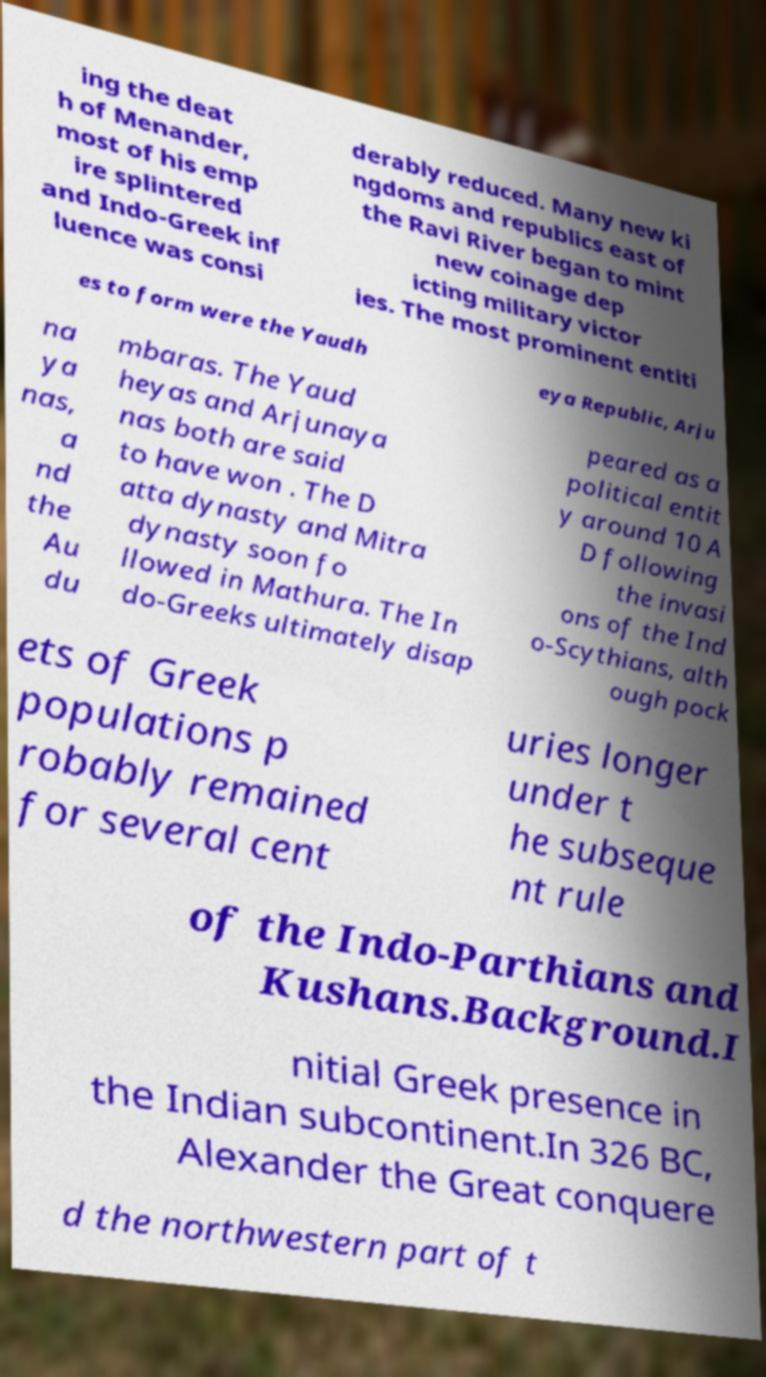Please identify and transcribe the text found in this image. ing the deat h of Menander, most of his emp ire splintered and Indo-Greek inf luence was consi derably reduced. Many new ki ngdoms and republics east of the Ravi River began to mint new coinage dep icting military victor ies. The most prominent entiti es to form were the Yaudh eya Republic, Arju na ya nas, a nd the Au du mbaras. The Yaud heyas and Arjunaya nas both are said to have won . The D atta dynasty and Mitra dynasty soon fo llowed in Mathura. The In do-Greeks ultimately disap peared as a political entit y around 10 A D following the invasi ons of the Ind o-Scythians, alth ough pock ets of Greek populations p robably remained for several cent uries longer under t he subseque nt rule of the Indo-Parthians and Kushans.Background.I nitial Greek presence in the Indian subcontinent.In 326 BC, Alexander the Great conquere d the northwestern part of t 